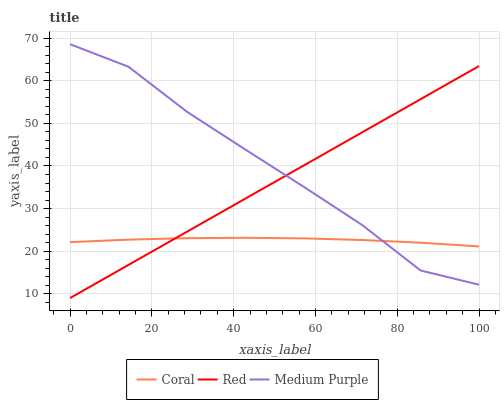Does Coral have the minimum area under the curve?
Answer yes or no. Yes. Does Medium Purple have the maximum area under the curve?
Answer yes or no. Yes. Does Red have the minimum area under the curve?
Answer yes or no. No. Does Red have the maximum area under the curve?
Answer yes or no. No. Is Red the smoothest?
Answer yes or no. Yes. Is Medium Purple the roughest?
Answer yes or no. Yes. Is Coral the smoothest?
Answer yes or no. No. Is Coral the roughest?
Answer yes or no. No. Does Coral have the lowest value?
Answer yes or no. No. Does Red have the highest value?
Answer yes or no. No. 